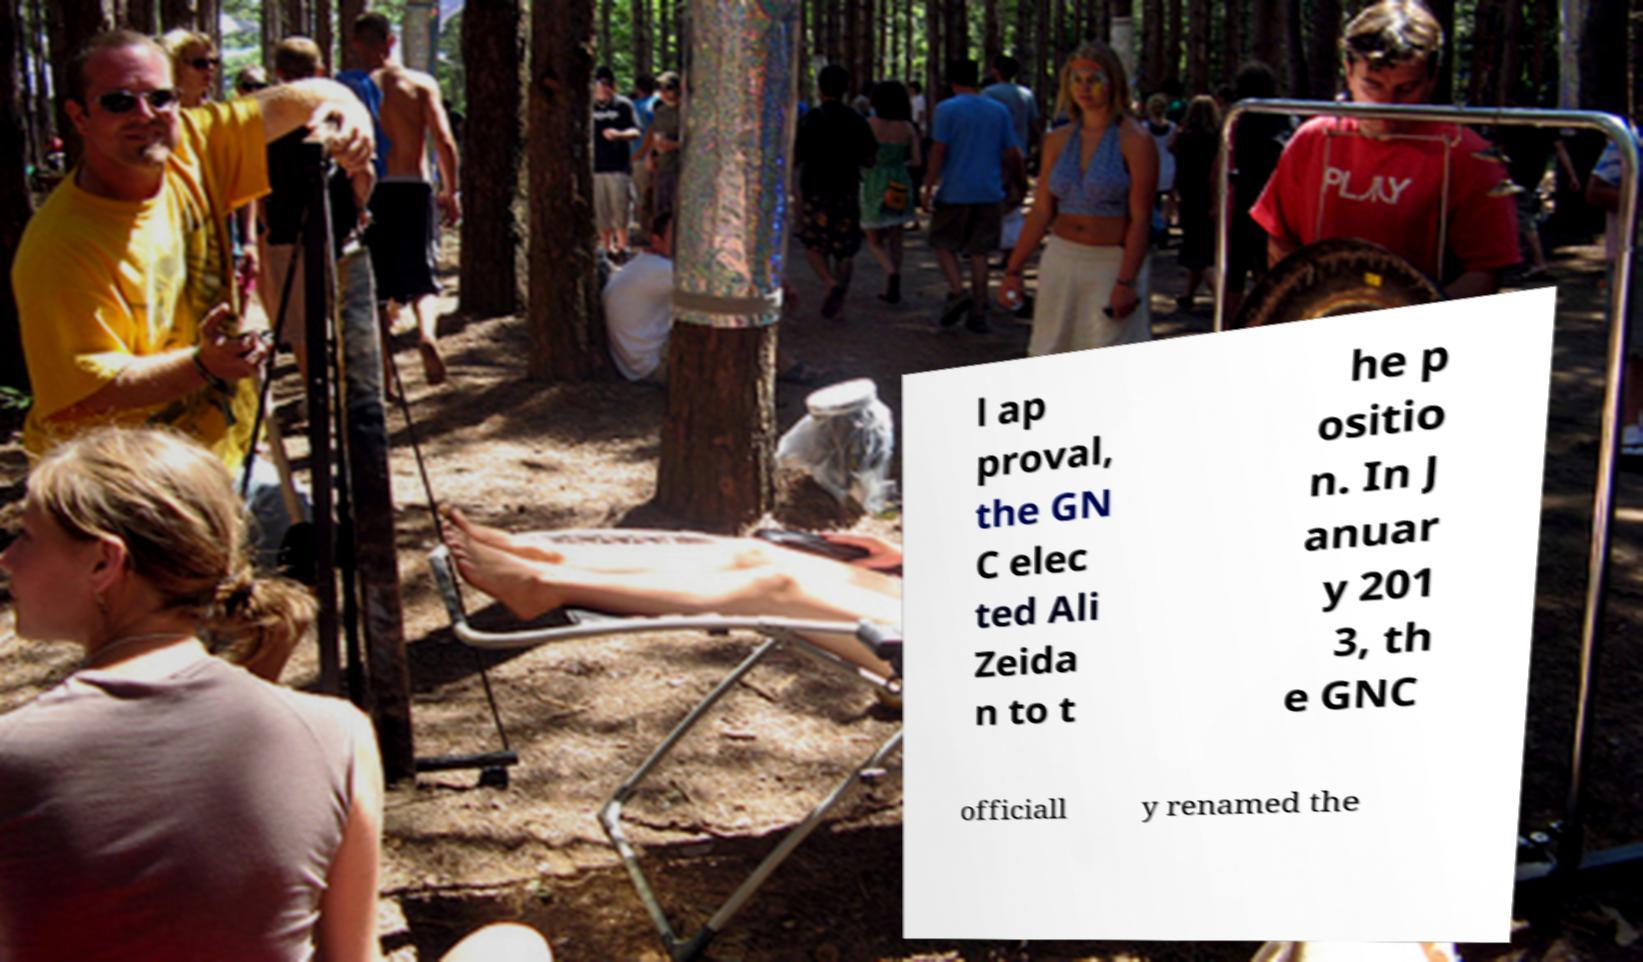Please identify and transcribe the text found in this image. l ap proval, the GN C elec ted Ali Zeida n to t he p ositio n. In J anuar y 201 3, th e GNC officiall y renamed the 